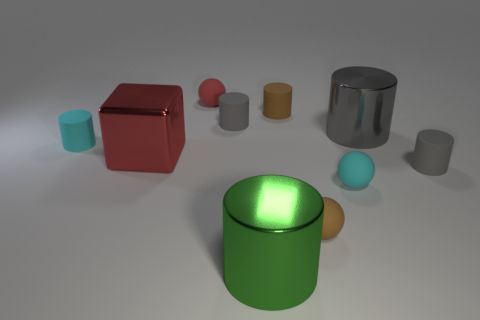Subtract all large cylinders. How many cylinders are left? 4 Subtract all gray blocks. How many gray cylinders are left? 3 Subtract all balls. How many objects are left? 7 Subtract all gray cylinders. How many cylinders are left? 3 Subtract all gray metal cylinders. Subtract all large gray things. How many objects are left? 8 Add 5 metallic cylinders. How many metallic cylinders are left? 7 Add 4 small brown cylinders. How many small brown cylinders exist? 5 Subtract 0 red cylinders. How many objects are left? 10 Subtract all brown blocks. Subtract all red cylinders. How many blocks are left? 1 